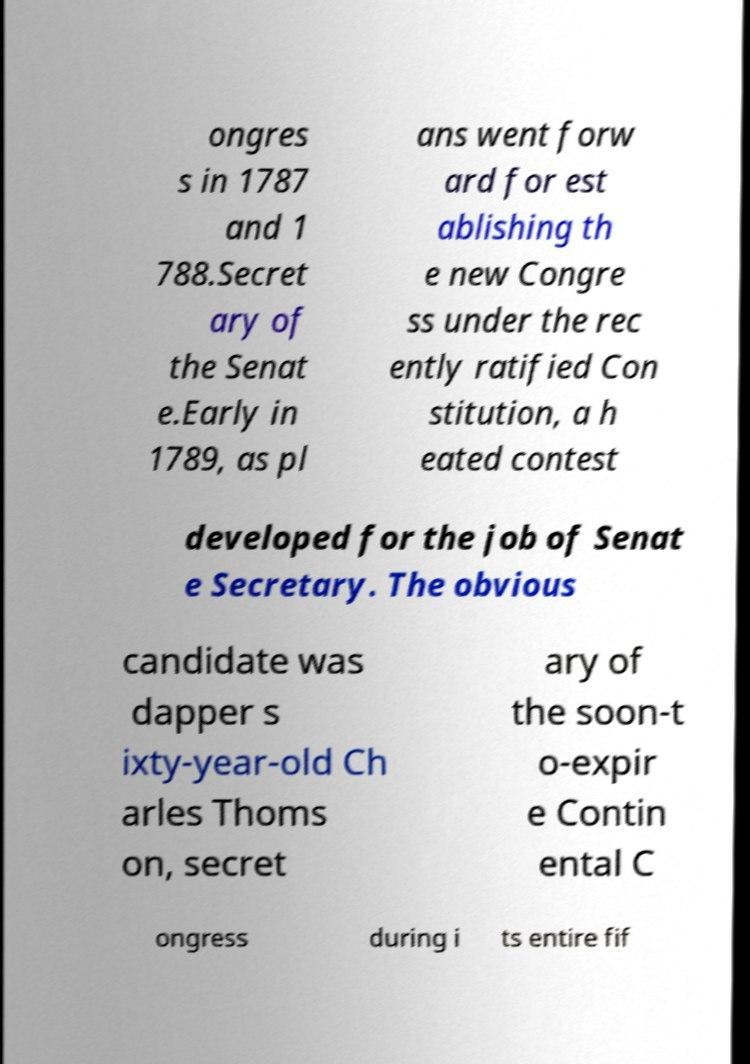Can you accurately transcribe the text from the provided image for me? ongres s in 1787 and 1 788.Secret ary of the Senat e.Early in 1789, as pl ans went forw ard for est ablishing th e new Congre ss under the rec ently ratified Con stitution, a h eated contest developed for the job of Senat e Secretary. The obvious candidate was dapper s ixty-year-old Ch arles Thoms on, secret ary of the soon-t o-expir e Contin ental C ongress during i ts entire fif 